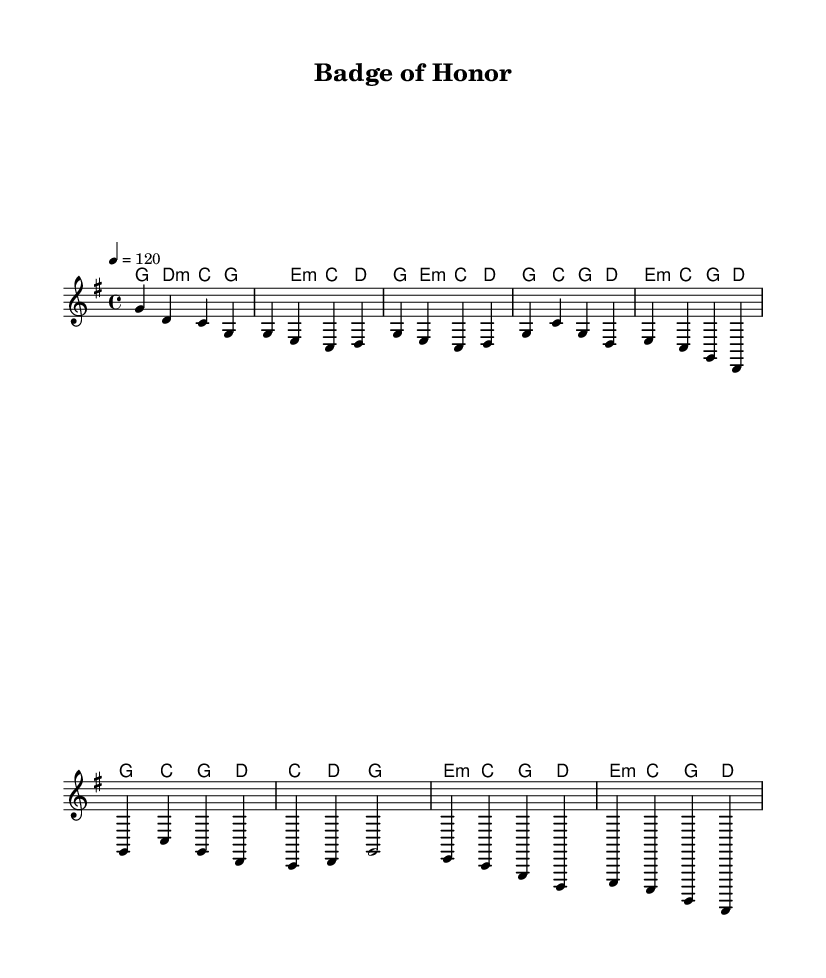What is the key signature of this music? The key signature is G major, which has one sharp (F#). This can be identified by looking at the key signature indicated at the beginning of the staff.
Answer: G major What is the time signature of this music? The time signature is 4/4, which means there are four beats in each measure and the quarter note gets one beat. This is found at the beginning of the score next to the key signature.
Answer: 4/4 What is the tempo marking of this music? The tempo marking is 120 beats per minute, indicated by the tempo "4 = 120" in the global section of the code.
Answer: 120 How many measures are in the chorus section? The chorus section contains four measures, which can be counted by identifying the four distinct lines of music designated for the chorus.
Answer: 4 What is the main theme expressed in this sheet music? The main theme expressed is patriotic appreciation for law enforcement, characterized by strong melodies and uplifting harmonies typical of country rock anthems. This reasoning is based on the title "Badge of Honor" and the overall purpose of the genre.
Answer: Patriotic appreciation What type of harmony is used in the chorus? The harmony used in the chorus is a mix of major and minor chords, primarily utilizing major chords for a uplifting feel while incorporating minor chords for emotional depth. This can be observed in the chord progression of the chorus section.
Answer: Major and minor chords 